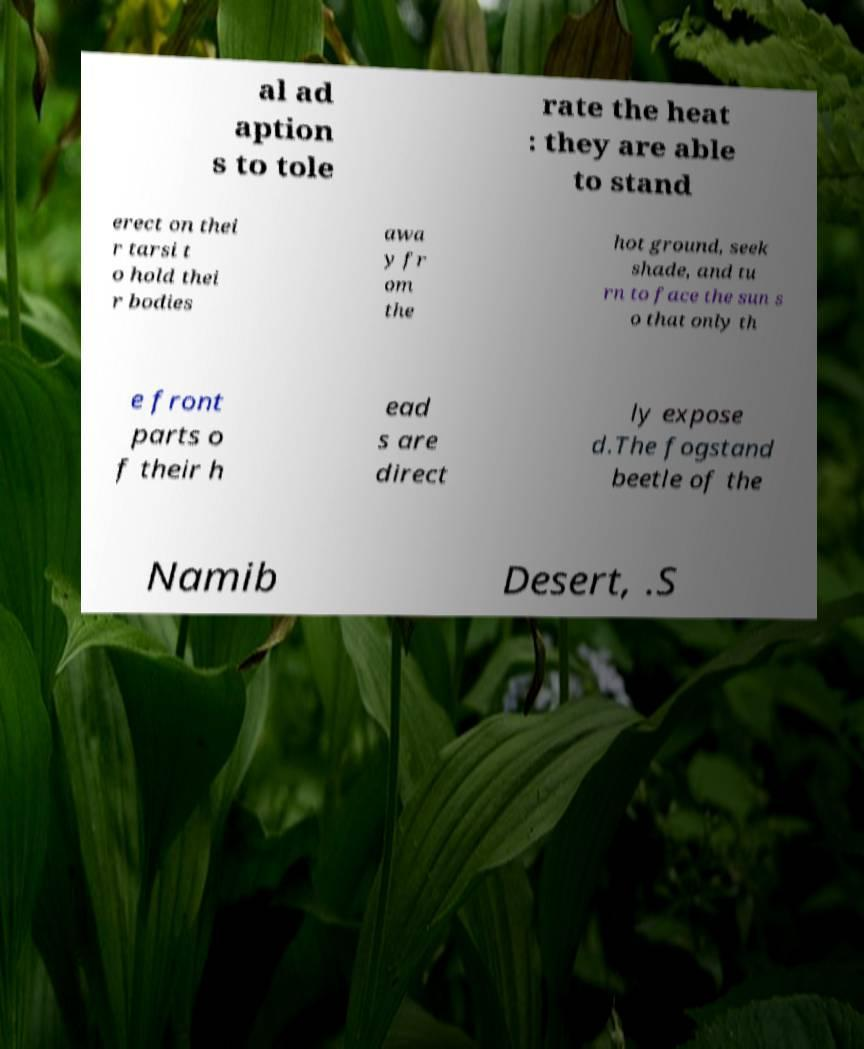Can you read and provide the text displayed in the image?This photo seems to have some interesting text. Can you extract and type it out for me? al ad aption s to tole rate the heat : they are able to stand erect on thei r tarsi t o hold thei r bodies awa y fr om the hot ground, seek shade, and tu rn to face the sun s o that only th e front parts o f their h ead s are direct ly expose d.The fogstand beetle of the Namib Desert, .S 